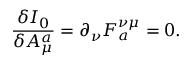<formula> <loc_0><loc_0><loc_500><loc_500>\frac { \delta I _ { 0 } } { \delta A _ { \mu } ^ { a } } = \partial _ { \nu } F _ { a } ^ { \nu \mu } = 0 .</formula> 